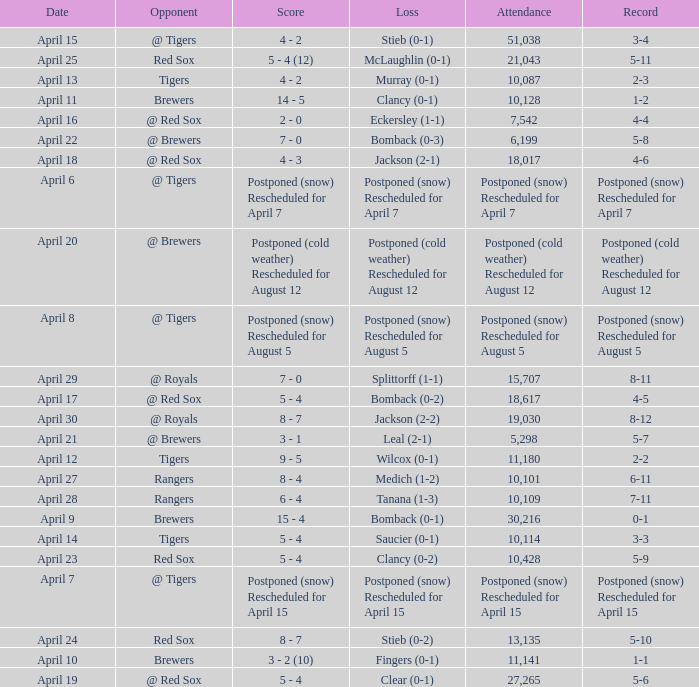What is the score for the game that has an attendance of 5,298? 3 - 1. 